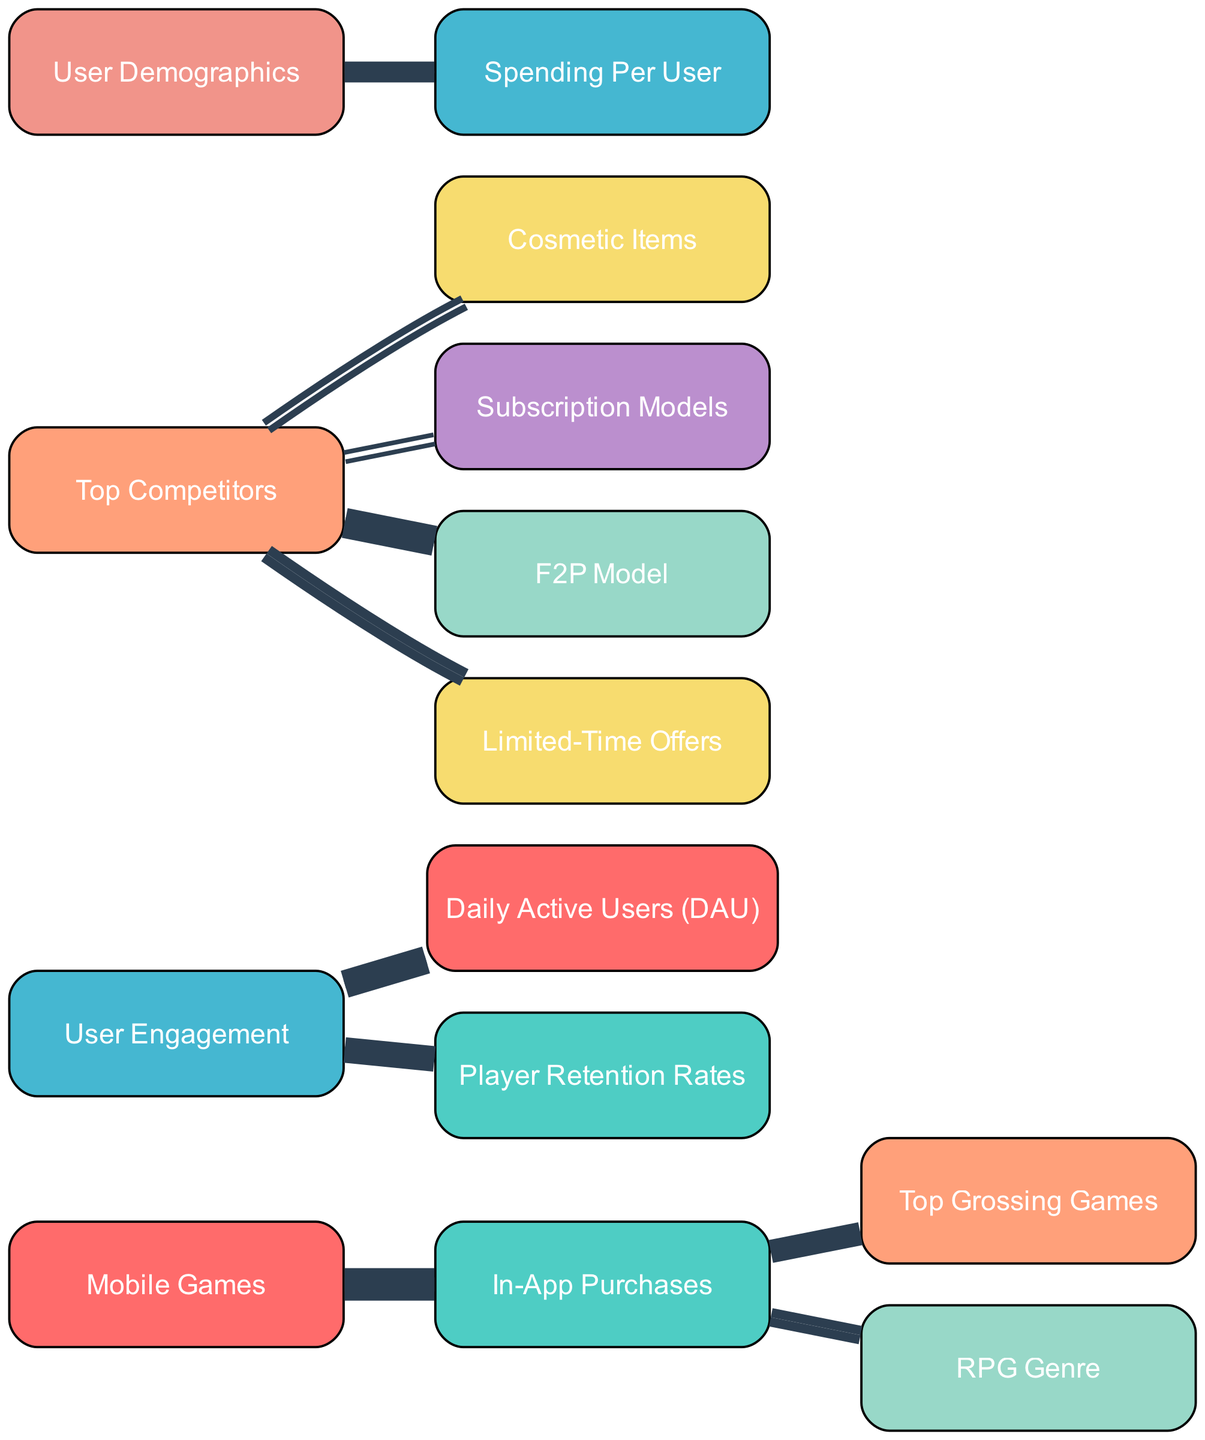What is the main category for the in-app purchases? The diagram indicates that "Mobile Games" is the primary source node leading to "In-App Purchases."
Answer: Mobile Games How many links are associated with the user engagement metric? The user engagement metric connects to two nodes: Daily Active Users (DAU) and Player Retention Rates, totaling two links.
Answer: 2 What is the spending value associated with the Top Competitors' F2P model? The link connecting "Top Competitors" to the "F2P Model" shows a value of 45, indicating spending related to this business model.
Answer: 45 Which purchase type has the least amount of spending from Top Competitors? The link from "Top Competitors" to "Subscription Models" shows a value of 10, which is lower than the others.
Answer: Subscription Models What percentage of in-app purchases contribute to top grossing games? There is a link from "In-App Purchases" to "Top Grossing Games" with a value of 30 out of 50 total purchases, resulting in 60%.
Answer: 60% In terms of user spending, which demographic factors are linked to spending? The diagram shows a direct link from "User Demographics" to "Spending Per User," emphasizing that demographics influence spending behavior.
Answer: User Demographics How many different types of purchase strategies are indicated in the diagram? The diagram includes three purchase strategies: Cosmetic Items, Subscription Models, and Limited-Time Offers, indicating three different strategies.
Answer: 3 Which genre shows a stronger link to user spending in terms of in-app purchases? The link from "In-App Purchases" to the "RPG Genre" displays a value of 20, indicating a robust connection to user spending.
Answer: RPG Genre What are the metrics associated with user engagement? There are two metrics related to user engagement: Daily Active Users (DAU) and Player Retention Rates, showing key aspects of user engagement.
Answer: Daily Active Users, Player Retention Rates 